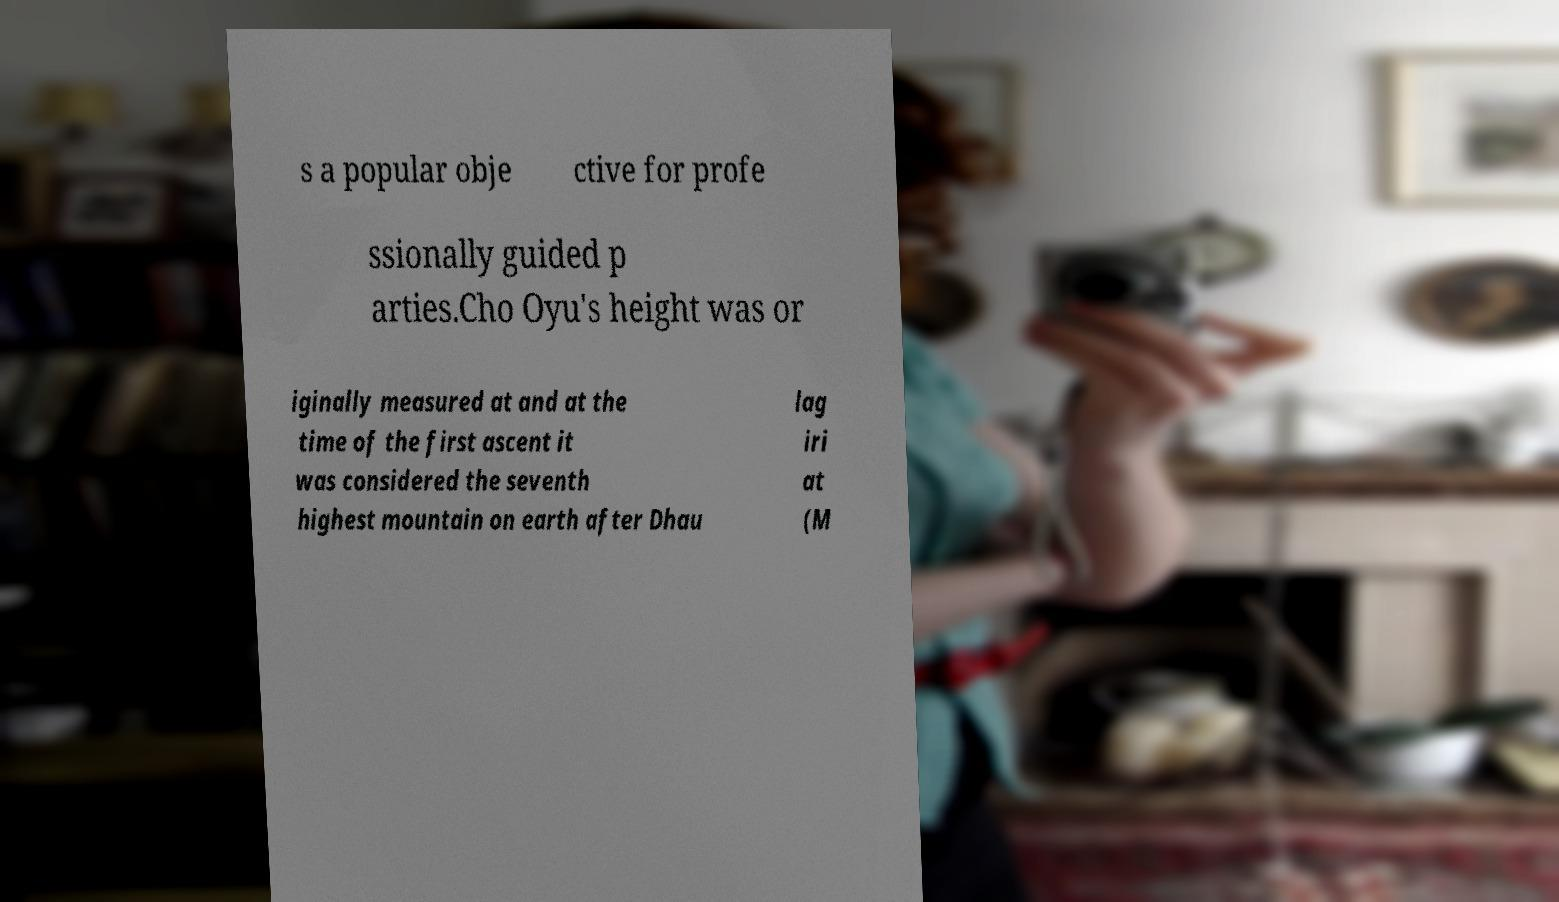I need the written content from this picture converted into text. Can you do that? s a popular obje ctive for profe ssionally guided p arties.Cho Oyu's height was or iginally measured at and at the time of the first ascent it was considered the seventh highest mountain on earth after Dhau lag iri at (M 